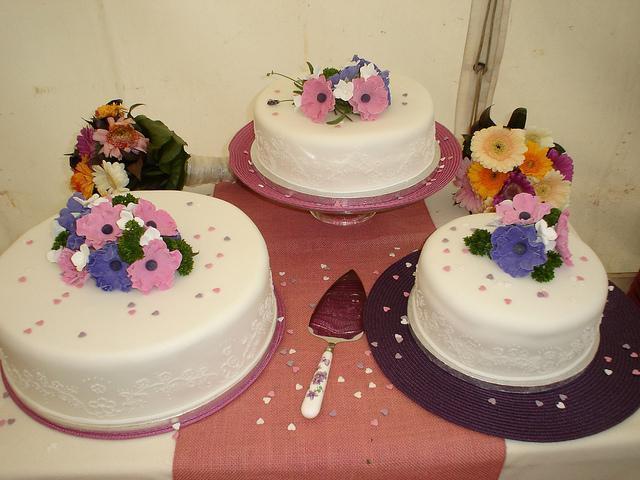What time of icing is on all of the cakes?
Pick the right solution, then justify: 'Answer: answer
Rationale: rationale.'
Options: Vanilla, strawberry, mint, chocolate. Answer: vanilla.
Rationale: It is a white frosting 